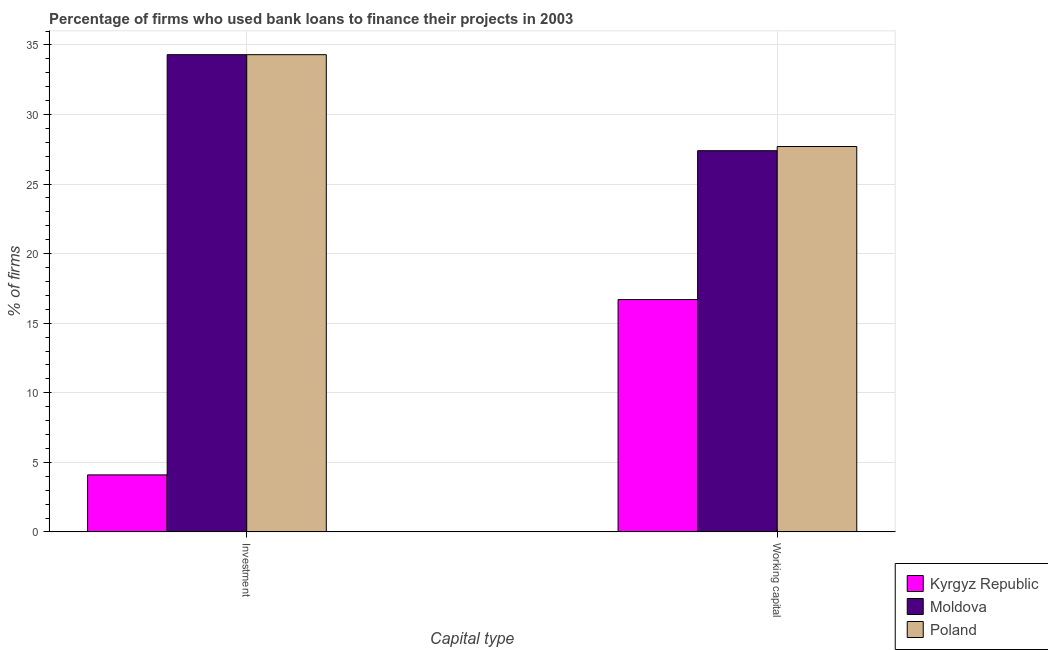How many different coloured bars are there?
Offer a very short reply. 3. Are the number of bars on each tick of the X-axis equal?
Your answer should be very brief. Yes. How many bars are there on the 1st tick from the left?
Ensure brevity in your answer.  3. How many bars are there on the 1st tick from the right?
Provide a succinct answer. 3. What is the label of the 1st group of bars from the left?
Offer a terse response. Investment. Across all countries, what is the maximum percentage of firms using banks to finance investment?
Keep it short and to the point. 34.3. In which country was the percentage of firms using banks to finance investment maximum?
Offer a very short reply. Moldova. In which country was the percentage of firms using banks to finance working capital minimum?
Offer a terse response. Kyrgyz Republic. What is the total percentage of firms using banks to finance investment in the graph?
Offer a terse response. 72.7. What is the difference between the percentage of firms using banks to finance investment in Poland and the percentage of firms using banks to finance working capital in Kyrgyz Republic?
Ensure brevity in your answer.  17.6. What is the average percentage of firms using banks to finance working capital per country?
Keep it short and to the point. 23.93. What is the difference between the percentage of firms using banks to finance working capital and percentage of firms using banks to finance investment in Poland?
Your answer should be compact. -6.6. In how many countries, is the percentage of firms using banks to finance working capital greater than 35 %?
Provide a succinct answer. 0. In how many countries, is the percentage of firms using banks to finance investment greater than the average percentage of firms using banks to finance investment taken over all countries?
Ensure brevity in your answer.  2. What does the 1st bar from the left in Investment represents?
Make the answer very short. Kyrgyz Republic. What does the 1st bar from the right in Working capital represents?
Make the answer very short. Poland. How many bars are there?
Ensure brevity in your answer.  6. Are all the bars in the graph horizontal?
Your answer should be compact. No. How many countries are there in the graph?
Your answer should be very brief. 3. What is the difference between two consecutive major ticks on the Y-axis?
Give a very brief answer. 5. Does the graph contain any zero values?
Provide a succinct answer. No. Does the graph contain grids?
Your response must be concise. Yes. What is the title of the graph?
Keep it short and to the point. Percentage of firms who used bank loans to finance their projects in 2003. Does "Canada" appear as one of the legend labels in the graph?
Your answer should be very brief. No. What is the label or title of the X-axis?
Your answer should be compact. Capital type. What is the label or title of the Y-axis?
Give a very brief answer. % of firms. What is the % of firms in Kyrgyz Republic in Investment?
Keep it short and to the point. 4.1. What is the % of firms of Moldova in Investment?
Ensure brevity in your answer.  34.3. What is the % of firms of Poland in Investment?
Provide a succinct answer. 34.3. What is the % of firms in Moldova in Working capital?
Offer a very short reply. 27.4. What is the % of firms in Poland in Working capital?
Make the answer very short. 27.7. Across all Capital type, what is the maximum % of firms of Kyrgyz Republic?
Provide a short and direct response. 16.7. Across all Capital type, what is the maximum % of firms in Moldova?
Ensure brevity in your answer.  34.3. Across all Capital type, what is the maximum % of firms in Poland?
Give a very brief answer. 34.3. Across all Capital type, what is the minimum % of firms in Moldova?
Offer a very short reply. 27.4. Across all Capital type, what is the minimum % of firms of Poland?
Your answer should be very brief. 27.7. What is the total % of firms of Kyrgyz Republic in the graph?
Offer a very short reply. 20.8. What is the total % of firms in Moldova in the graph?
Offer a very short reply. 61.7. What is the difference between the % of firms in Kyrgyz Republic in Investment and the % of firms in Moldova in Working capital?
Your answer should be compact. -23.3. What is the difference between the % of firms in Kyrgyz Republic in Investment and the % of firms in Poland in Working capital?
Make the answer very short. -23.6. What is the average % of firms of Kyrgyz Republic per Capital type?
Ensure brevity in your answer.  10.4. What is the average % of firms of Moldova per Capital type?
Your response must be concise. 30.85. What is the average % of firms in Poland per Capital type?
Your answer should be compact. 31. What is the difference between the % of firms in Kyrgyz Republic and % of firms in Moldova in Investment?
Your answer should be compact. -30.2. What is the difference between the % of firms in Kyrgyz Republic and % of firms in Poland in Investment?
Ensure brevity in your answer.  -30.2. What is the difference between the % of firms of Moldova and % of firms of Poland in Investment?
Offer a very short reply. 0. What is the difference between the % of firms in Moldova and % of firms in Poland in Working capital?
Your answer should be very brief. -0.3. What is the ratio of the % of firms in Kyrgyz Republic in Investment to that in Working capital?
Offer a very short reply. 0.25. What is the ratio of the % of firms of Moldova in Investment to that in Working capital?
Offer a terse response. 1.25. What is the ratio of the % of firms in Poland in Investment to that in Working capital?
Provide a succinct answer. 1.24. What is the difference between the highest and the lowest % of firms of Kyrgyz Republic?
Your response must be concise. 12.6. What is the difference between the highest and the lowest % of firms of Poland?
Your answer should be very brief. 6.6. 